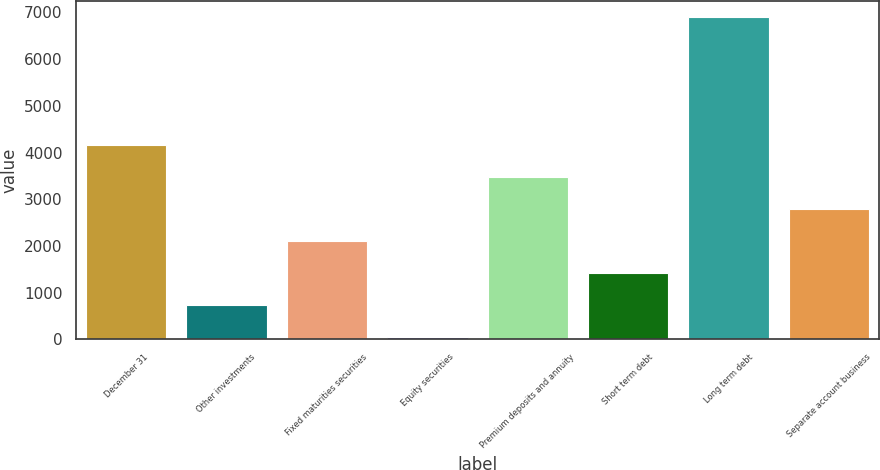<chart> <loc_0><loc_0><loc_500><loc_500><bar_chart><fcel>December 31<fcel>Other investments<fcel>Fixed maturities securities<fcel>Equity securities<fcel>Premium deposits and annuity<fcel>Short term debt<fcel>Long term debt<fcel>Separate account business<nl><fcel>4158<fcel>730.5<fcel>2101.5<fcel>45<fcel>3472.5<fcel>1416<fcel>6900<fcel>2787<nl></chart> 